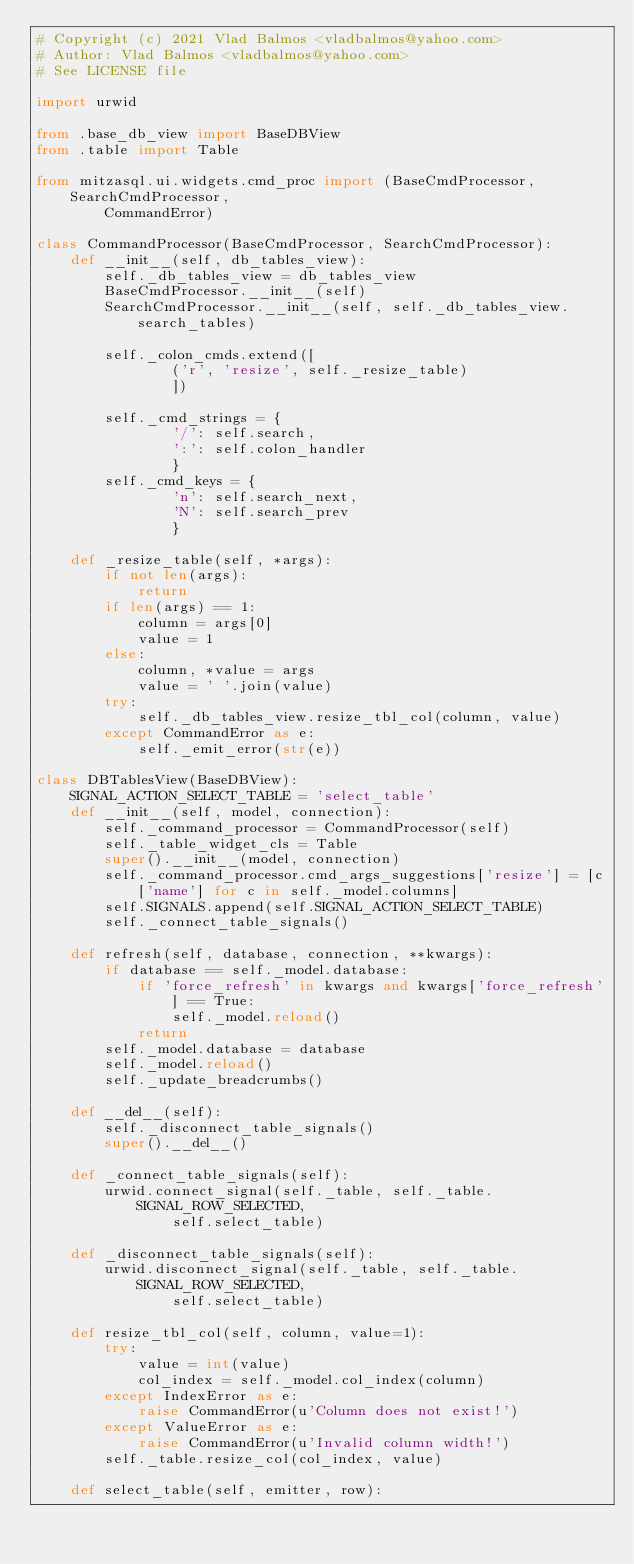<code> <loc_0><loc_0><loc_500><loc_500><_Python_># Copyright (c) 2021 Vlad Balmos <vladbalmos@yahoo.com>
# Author: Vlad Balmos <vladbalmos@yahoo.com>
# See LICENSE file

import urwid

from .base_db_view import BaseDBView
from .table import Table

from mitzasql.ui.widgets.cmd_proc import (BaseCmdProcessor, SearchCmdProcessor,
        CommandError)

class CommandProcessor(BaseCmdProcessor, SearchCmdProcessor):
    def __init__(self, db_tables_view):
        self._db_tables_view = db_tables_view
        BaseCmdProcessor.__init__(self)
        SearchCmdProcessor.__init__(self, self._db_tables_view.search_tables)

        self._colon_cmds.extend([
                ('r', 'resize', self._resize_table)
                ])

        self._cmd_strings = {
                '/': self.search,
                ':': self.colon_handler
                }
        self._cmd_keys = {
                'n': self.search_next,
                'N': self.search_prev
                }

    def _resize_table(self, *args):
        if not len(args):
            return
        if len(args) == 1:
            column = args[0]
            value = 1
        else:
            column, *value = args
            value = ' '.join(value)
        try:
            self._db_tables_view.resize_tbl_col(column, value)
        except CommandError as e:
            self._emit_error(str(e))

class DBTablesView(BaseDBView):
    SIGNAL_ACTION_SELECT_TABLE = 'select_table'
    def __init__(self, model, connection):
        self._command_processor = CommandProcessor(self)
        self._table_widget_cls = Table
        super().__init__(model, connection)
        self._command_processor.cmd_args_suggestions['resize'] = [c['name'] for c in self._model.columns]
        self.SIGNALS.append(self.SIGNAL_ACTION_SELECT_TABLE)
        self._connect_table_signals()

    def refresh(self, database, connection, **kwargs):
        if database == self._model.database:
            if 'force_refresh' in kwargs and kwargs['force_refresh'] == True:
                self._model.reload()
            return
        self._model.database = database
        self._model.reload()
        self._update_breadcrumbs()

    def __del__(self):
        self._disconnect_table_signals()
        super().__del__()

    def _connect_table_signals(self):
        urwid.connect_signal(self._table, self._table.SIGNAL_ROW_SELECTED,
                self.select_table)

    def _disconnect_table_signals(self):
        urwid.disconnect_signal(self._table, self._table.SIGNAL_ROW_SELECTED,
                self.select_table)

    def resize_tbl_col(self, column, value=1):
        try:
            value = int(value)
            col_index = self._model.col_index(column)
        except IndexError as e:
            raise CommandError(u'Column does not exist!')
        except ValueError as e:
            raise CommandError(u'Invalid column width!')
        self._table.resize_col(col_index, value)

    def select_table(self, emitter, row):</code> 